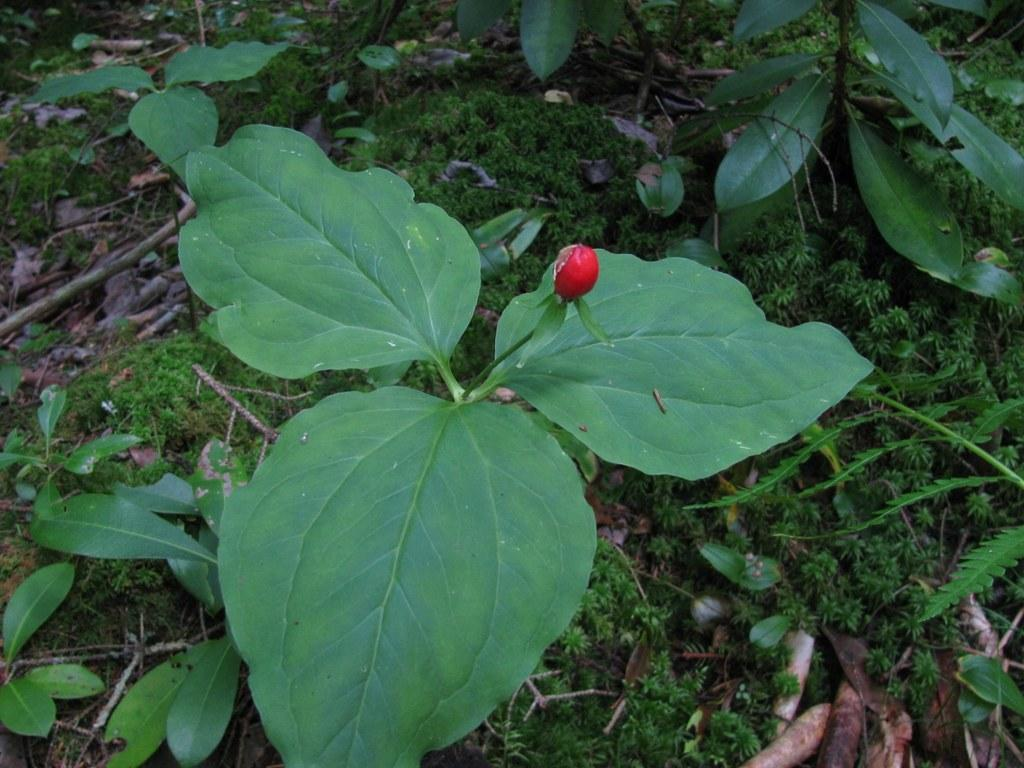What is the color of the bud on the plant in the image? The bud on the plant is red. What type of vegetation can be seen in the image? There is greenery in the image. What is the condition of some of the plant parts in the image? Dry stems and leaves are present in the image. What type of chin can be seen on the plant in the image? There is no chin present on the plant in the image, as plants do not have chins. 